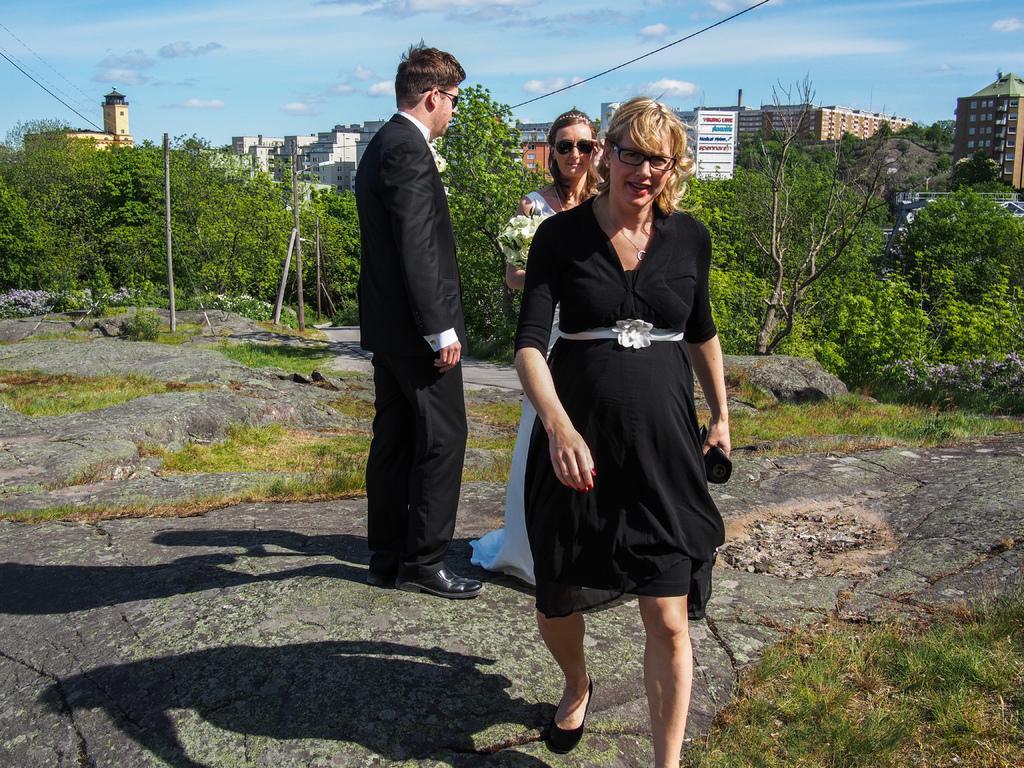Describe this image in one or two sentences. In this image, in the middle there is a woman, she is walking, behind her there is a woman, she is holding a bouquet. On the left there is a man, he is standing. In the background there are trees, buildings, cables, sticks, grass, posters, sky and clouds. 